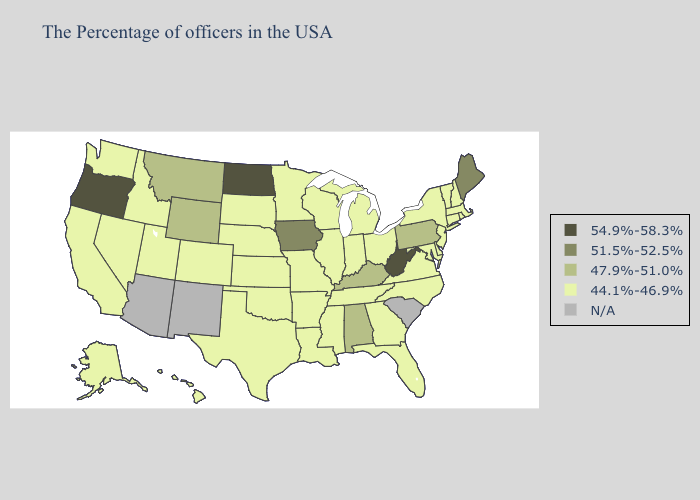Name the states that have a value in the range 54.9%-58.3%?
Concise answer only. West Virginia, North Dakota, Oregon. What is the highest value in states that border Arkansas?
Write a very short answer. 44.1%-46.9%. What is the lowest value in states that border New Mexico?
Keep it brief. 44.1%-46.9%. Name the states that have a value in the range 54.9%-58.3%?
Give a very brief answer. West Virginia, North Dakota, Oregon. Name the states that have a value in the range 44.1%-46.9%?
Keep it brief. Massachusetts, Rhode Island, New Hampshire, Vermont, Connecticut, New York, New Jersey, Delaware, Maryland, Virginia, North Carolina, Ohio, Florida, Georgia, Michigan, Indiana, Tennessee, Wisconsin, Illinois, Mississippi, Louisiana, Missouri, Arkansas, Minnesota, Kansas, Nebraska, Oklahoma, Texas, South Dakota, Colorado, Utah, Idaho, Nevada, California, Washington, Alaska, Hawaii. What is the lowest value in states that border Montana?
Concise answer only. 44.1%-46.9%. Which states have the lowest value in the West?
Write a very short answer. Colorado, Utah, Idaho, Nevada, California, Washington, Alaska, Hawaii. What is the lowest value in states that border Washington?
Give a very brief answer. 44.1%-46.9%. Which states have the lowest value in the South?
Keep it brief. Delaware, Maryland, Virginia, North Carolina, Florida, Georgia, Tennessee, Mississippi, Louisiana, Arkansas, Oklahoma, Texas. Does Maine have the highest value in the Northeast?
Keep it brief. Yes. What is the value of Wisconsin?
Answer briefly. 44.1%-46.9%. Name the states that have a value in the range 47.9%-51.0%?
Answer briefly. Pennsylvania, Kentucky, Alabama, Wyoming, Montana. What is the value of Nevada?
Answer briefly. 44.1%-46.9%. What is the value of Michigan?
Give a very brief answer. 44.1%-46.9%. Does the first symbol in the legend represent the smallest category?
Short answer required. No. 